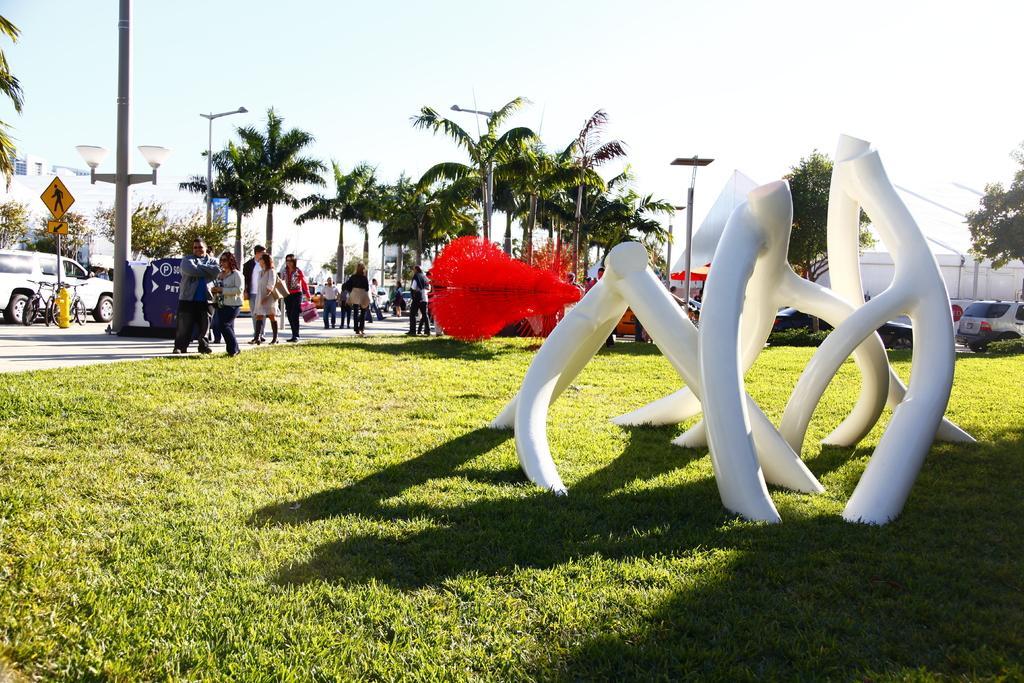How would you summarize this image in a sentence or two? In the foreground I can see a sculpture and grass. In the background I can see a crowd, vehicles on the road, trees and a fountain. At the top I can see the sky. This image is taken during a day on the road. 